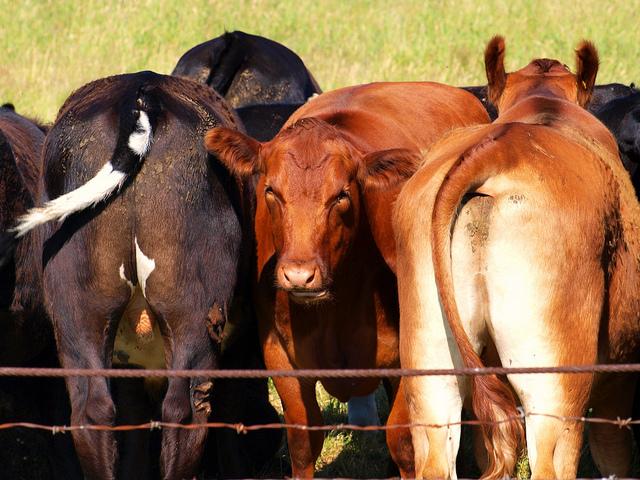What color is the cow on the left?
Answer briefly. Black. How many cows are facing the camera?
Answer briefly. 1. Does this look like a farm?
Be succinct. Yes. 